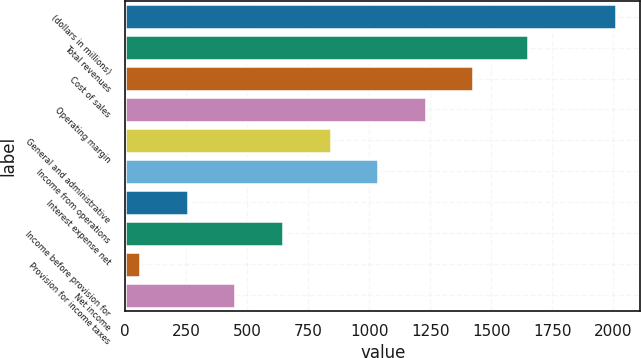<chart> <loc_0><loc_0><loc_500><loc_500><bar_chart><fcel>(dollars in millions)<fcel>Total revenues<fcel>Cost of sales<fcel>Operating margin<fcel>General and administrative<fcel>Income from operations<fcel>Interest expense net<fcel>Income before provision for<fcel>Provision for income taxes<fcel>Net income<nl><fcel>2011<fcel>1652.2<fcel>1426.42<fcel>1231.56<fcel>841.84<fcel>1036.7<fcel>257.26<fcel>646.98<fcel>62.4<fcel>452.12<nl></chart> 